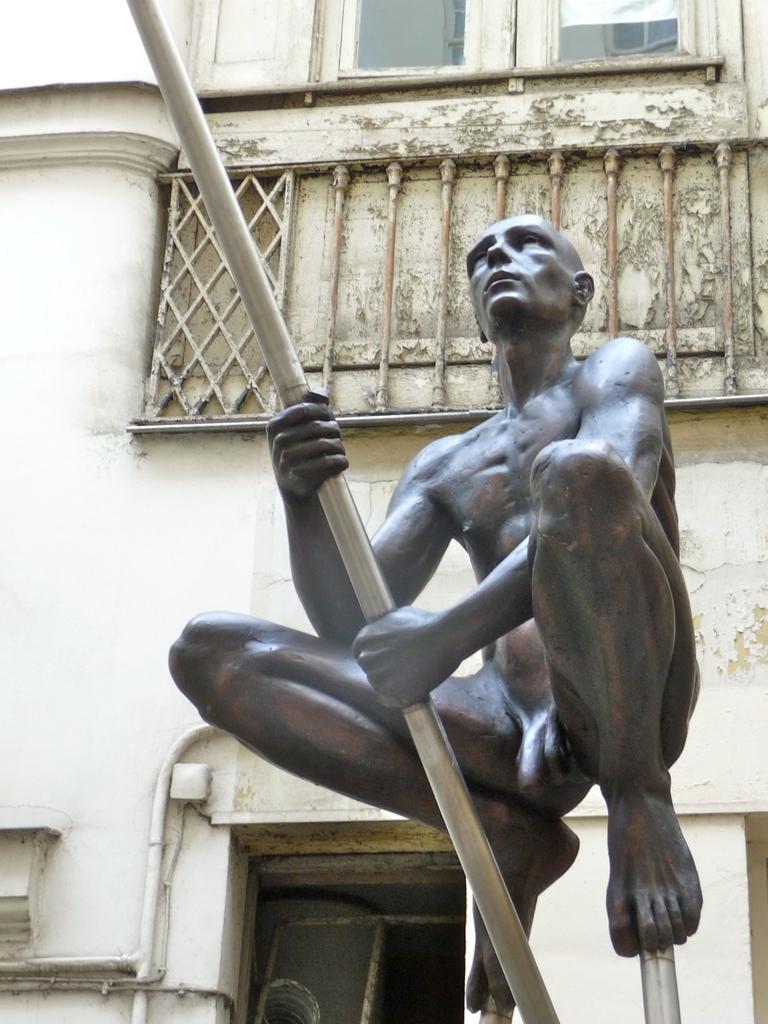In one or two sentences, can you explain what this image depicts? This is the statue of a person jumping and holding a pipe. I think this is the building with windows. This is the pipe, which is attached to the wall. 